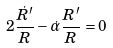Convert formula to latex. <formula><loc_0><loc_0><loc_500><loc_500>2 \frac { \dot { R } ^ { \prime } } { R } - \dot { \alpha } \frac { R ^ { \prime } } { R } = 0</formula> 